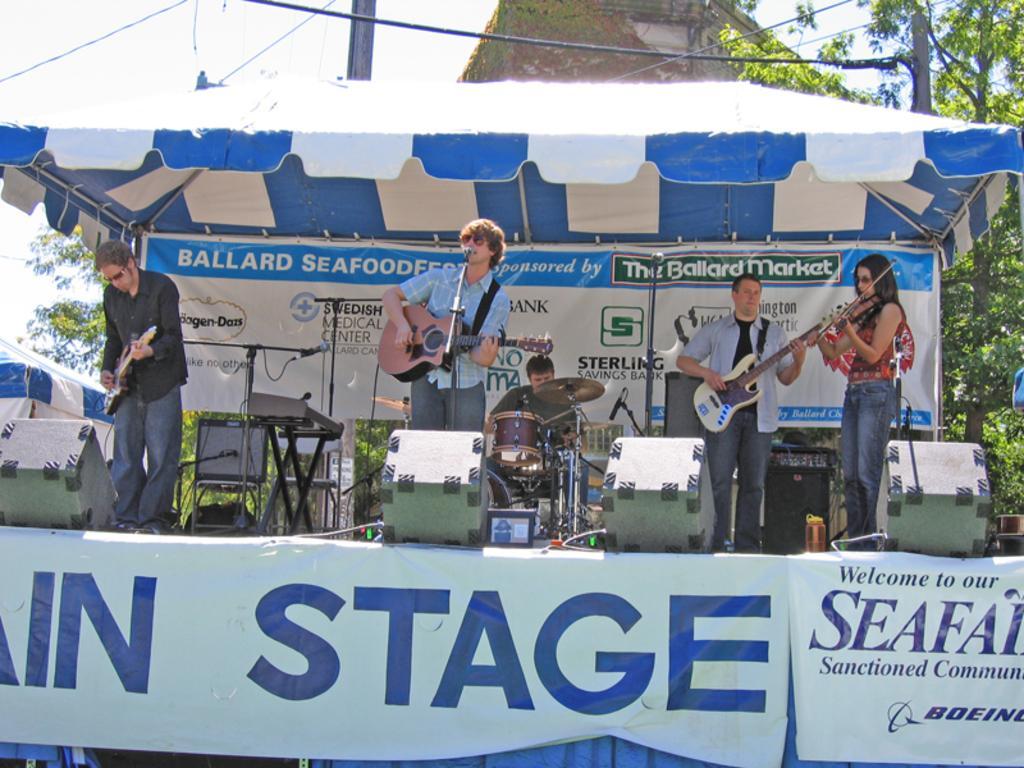Can you describe this image briefly? There are four people standing on a stage. They are playing a musical instruments. In the center we have a person. His sitting on a chair. We can see the background there is a trees,sky,banner. 